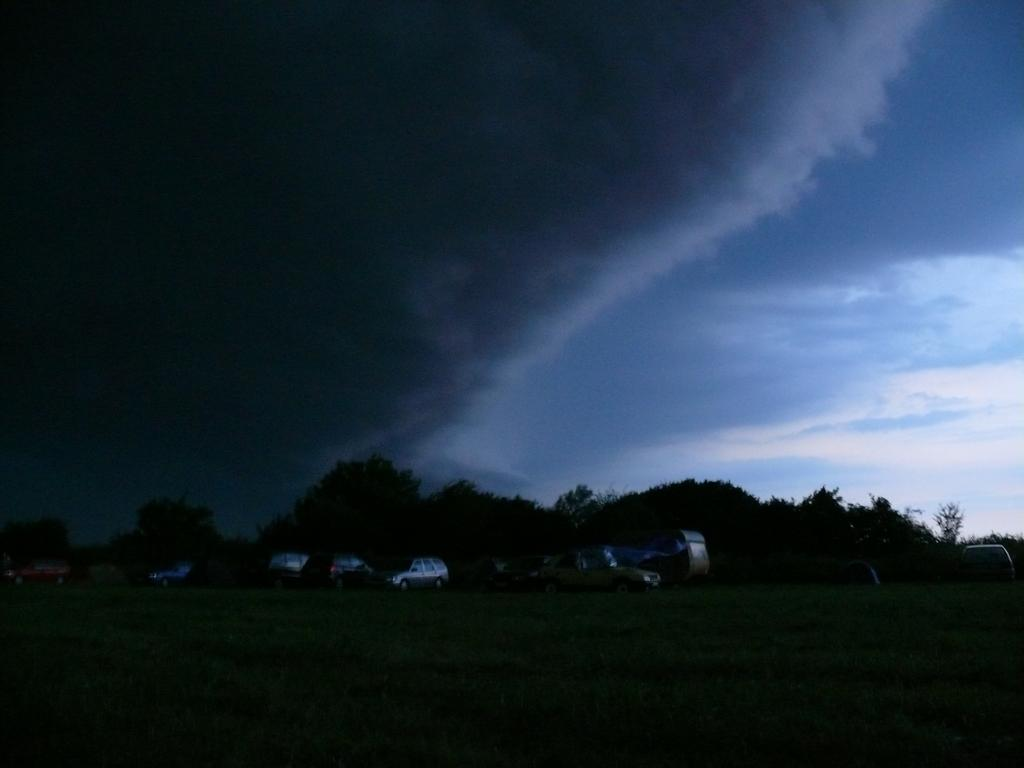What types of objects are present in the image? There are vehicles in the image. What can be seen in the background of the image? There are trees in the background of the image. How would you describe the sky in the image? The sky is cloudy in the image. Are there any fairies flying around the vehicles in the image? No, there are no fairies present in the image. What type of lunch is being served in the image? There is no lunch depicted in the image; it only features vehicles and a cloudy sky. 